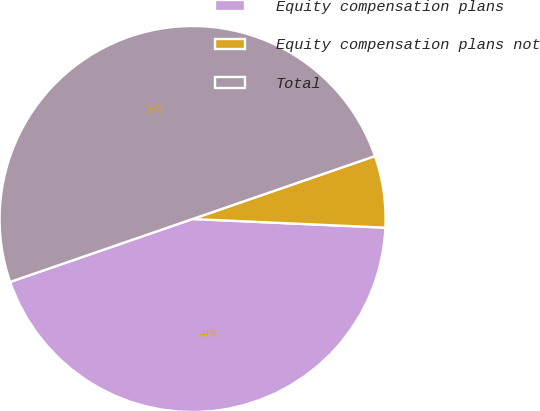Convert chart to OTSL. <chart><loc_0><loc_0><loc_500><loc_500><pie_chart><fcel>Equity compensation plans<fcel>Equity compensation plans not<fcel>Total<nl><fcel>44.0%<fcel>6.0%<fcel>50.0%<nl></chart> 